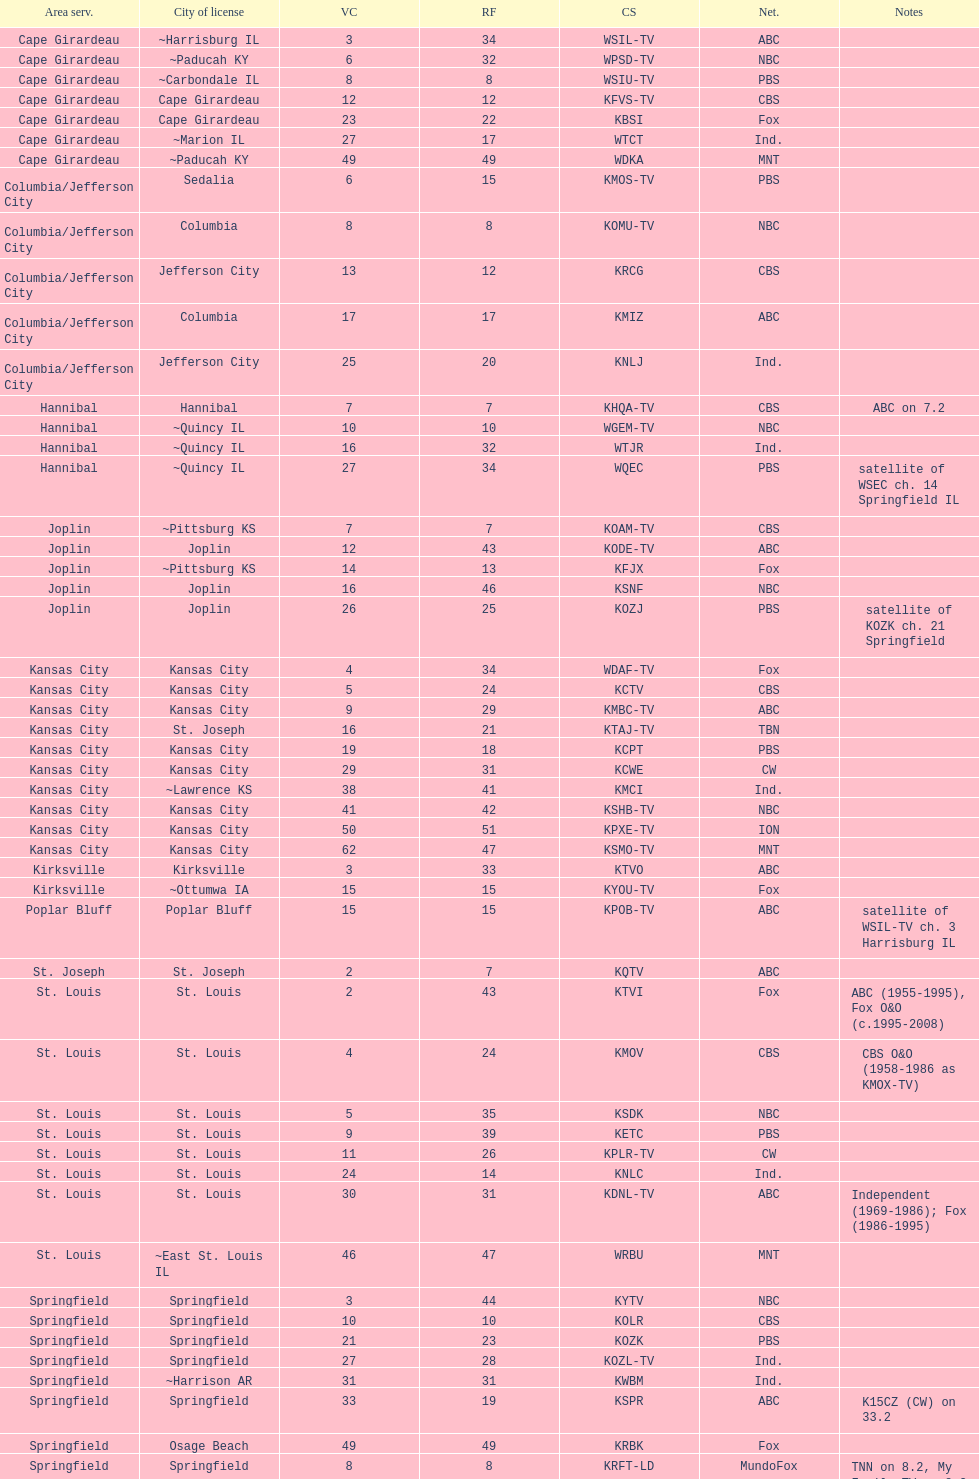Kode-tv and wsil-tv both are a part of which network? ABC. 